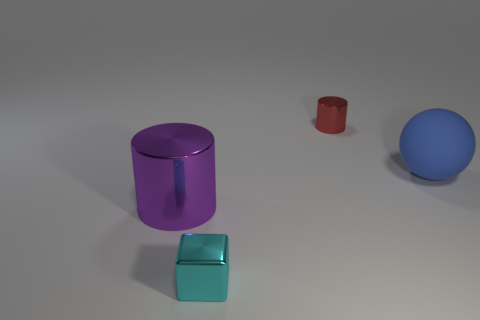Add 4 big yellow metal balls. How many objects exist? 8 Subtract all large green cubes. Subtract all metallic things. How many objects are left? 1 Add 4 big blue matte objects. How many big blue matte objects are left? 5 Add 4 small metallic things. How many small metallic things exist? 6 Subtract 0 brown cylinders. How many objects are left? 4 Subtract all balls. How many objects are left? 3 Subtract all red spheres. Subtract all cyan cylinders. How many spheres are left? 1 